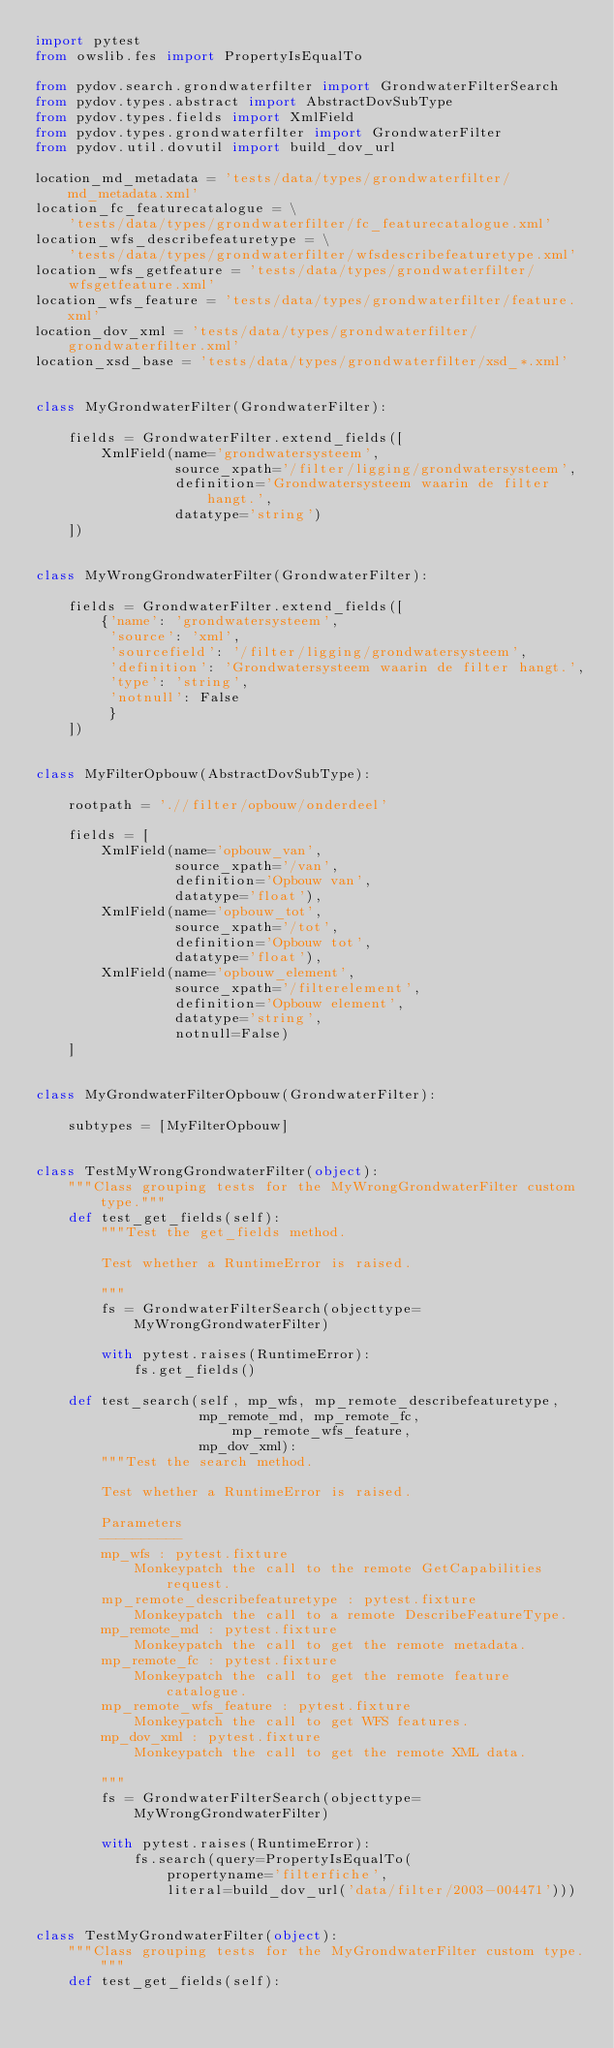Convert code to text. <code><loc_0><loc_0><loc_500><loc_500><_Python_>import pytest
from owslib.fes import PropertyIsEqualTo

from pydov.search.grondwaterfilter import GrondwaterFilterSearch
from pydov.types.abstract import AbstractDovSubType
from pydov.types.fields import XmlField
from pydov.types.grondwaterfilter import GrondwaterFilter
from pydov.util.dovutil import build_dov_url

location_md_metadata = 'tests/data/types/grondwaterfilter/md_metadata.xml'
location_fc_featurecatalogue = \
    'tests/data/types/grondwaterfilter/fc_featurecatalogue.xml'
location_wfs_describefeaturetype = \
    'tests/data/types/grondwaterfilter/wfsdescribefeaturetype.xml'
location_wfs_getfeature = 'tests/data/types/grondwaterfilter/wfsgetfeature.xml'
location_wfs_feature = 'tests/data/types/grondwaterfilter/feature.xml'
location_dov_xml = 'tests/data/types/grondwaterfilter/grondwaterfilter.xml'
location_xsd_base = 'tests/data/types/grondwaterfilter/xsd_*.xml'


class MyGrondwaterFilter(GrondwaterFilter):

    fields = GrondwaterFilter.extend_fields([
        XmlField(name='grondwatersysteem',
                 source_xpath='/filter/ligging/grondwatersysteem',
                 definition='Grondwatersysteem waarin de filter hangt.',
                 datatype='string')
    ])


class MyWrongGrondwaterFilter(GrondwaterFilter):

    fields = GrondwaterFilter.extend_fields([
        {'name': 'grondwatersysteem',
         'source': 'xml',
         'sourcefield': '/filter/ligging/grondwatersysteem',
         'definition': 'Grondwatersysteem waarin de filter hangt.',
         'type': 'string',
         'notnull': False
         }
    ])


class MyFilterOpbouw(AbstractDovSubType):

    rootpath = './/filter/opbouw/onderdeel'

    fields = [
        XmlField(name='opbouw_van',
                 source_xpath='/van',
                 definition='Opbouw van',
                 datatype='float'),
        XmlField(name='opbouw_tot',
                 source_xpath='/tot',
                 definition='Opbouw tot',
                 datatype='float'),
        XmlField(name='opbouw_element',
                 source_xpath='/filterelement',
                 definition='Opbouw element',
                 datatype='string',
                 notnull=False)
    ]


class MyGrondwaterFilterOpbouw(GrondwaterFilter):

    subtypes = [MyFilterOpbouw]


class TestMyWrongGrondwaterFilter(object):
    """Class grouping tests for the MyWrongGrondwaterFilter custom type."""
    def test_get_fields(self):
        """Test the get_fields method.

        Test whether a RuntimeError is raised.

        """
        fs = GrondwaterFilterSearch(objecttype=MyWrongGrondwaterFilter)

        with pytest.raises(RuntimeError):
            fs.get_fields()

    def test_search(self, mp_wfs, mp_remote_describefeaturetype,
                    mp_remote_md, mp_remote_fc, mp_remote_wfs_feature,
                    mp_dov_xml):
        """Test the search method.

        Test whether a RuntimeError is raised.

        Parameters
        ----------
        mp_wfs : pytest.fixture
            Monkeypatch the call to the remote GetCapabilities request.
        mp_remote_describefeaturetype : pytest.fixture
            Monkeypatch the call to a remote DescribeFeatureType.
        mp_remote_md : pytest.fixture
            Monkeypatch the call to get the remote metadata.
        mp_remote_fc : pytest.fixture
            Monkeypatch the call to get the remote feature catalogue.
        mp_remote_wfs_feature : pytest.fixture
            Monkeypatch the call to get WFS features.
        mp_dov_xml : pytest.fixture
            Monkeypatch the call to get the remote XML data.

        """
        fs = GrondwaterFilterSearch(objecttype=MyWrongGrondwaterFilter)

        with pytest.raises(RuntimeError):
            fs.search(query=PropertyIsEqualTo(
                propertyname='filterfiche',
                literal=build_dov_url('data/filter/2003-004471')))


class TestMyGrondwaterFilter(object):
    """Class grouping tests for the MyGrondwaterFilter custom type."""
    def test_get_fields(self):</code> 